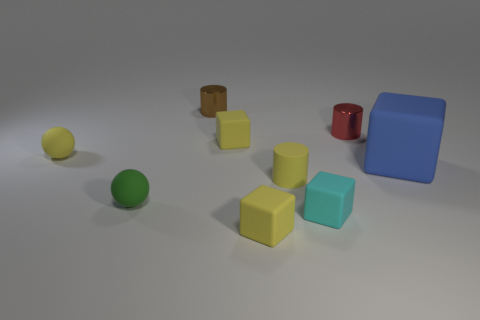The small matte cylinder has what color?
Ensure brevity in your answer.  Yellow. Does the metallic thing on the right side of the small cyan block have the same shape as the green thing?
Your answer should be compact. No. What shape is the thing that is behind the shiny cylinder right of the tiny yellow matte cylinder that is to the right of the small brown cylinder?
Your response must be concise. Cylinder. What is the material of the red thing behind the cyan object?
Your answer should be very brief. Metal. There is another matte ball that is the same size as the green rubber ball; what color is it?
Provide a succinct answer. Yellow. What number of other things are there of the same shape as the green matte thing?
Offer a terse response. 1. Do the green matte sphere and the blue object have the same size?
Offer a very short reply. No. Is the number of small yellow matte things that are to the left of the tiny brown object greater than the number of small green things left of the tiny green ball?
Offer a very short reply. Yes. How many other objects are the same size as the green ball?
Ensure brevity in your answer.  7. Does the metallic object that is in front of the tiny brown cylinder have the same color as the big matte thing?
Ensure brevity in your answer.  No. 